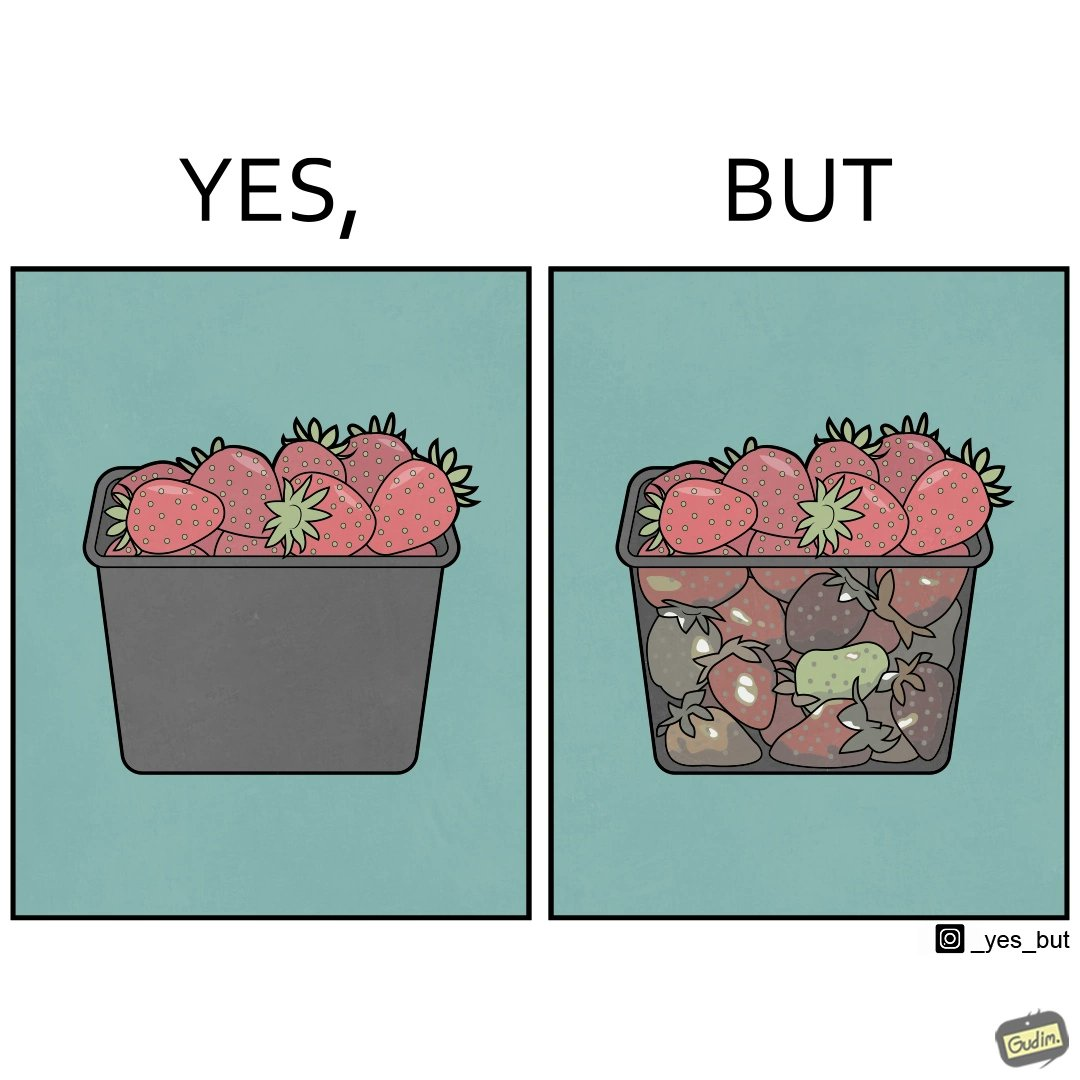Describe what you see in this image. the image is funny, as the strawberries in a container generally bought in retail appear fresh from the top, but the ones below them (which are generally not visible directly while buying the container of strawberries) are low quality/spoilt, revealing the tactics that retail uses to pass on low-quality products to innocent consumers. 